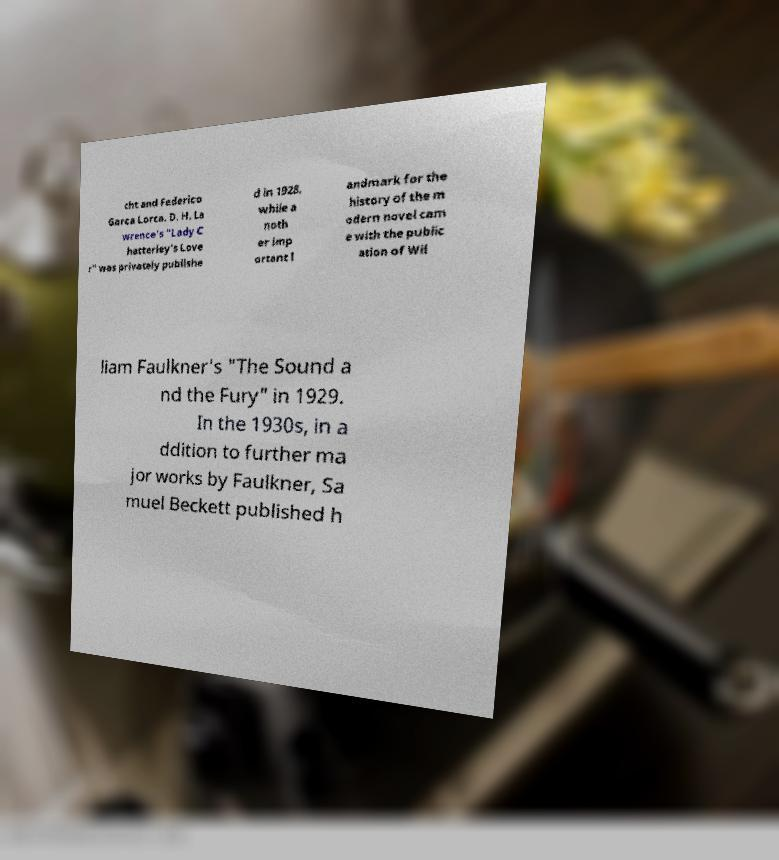Can you read and provide the text displayed in the image?This photo seems to have some interesting text. Can you extract and type it out for me? cht and Federico Garca Lorca. D. H. La wrence's "Lady C hatterley's Love r" was privately publishe d in 1928, while a noth er imp ortant l andmark for the history of the m odern novel cam e with the public ation of Wil liam Faulkner's "The Sound a nd the Fury" in 1929. In the 1930s, in a ddition to further ma jor works by Faulkner, Sa muel Beckett published h 